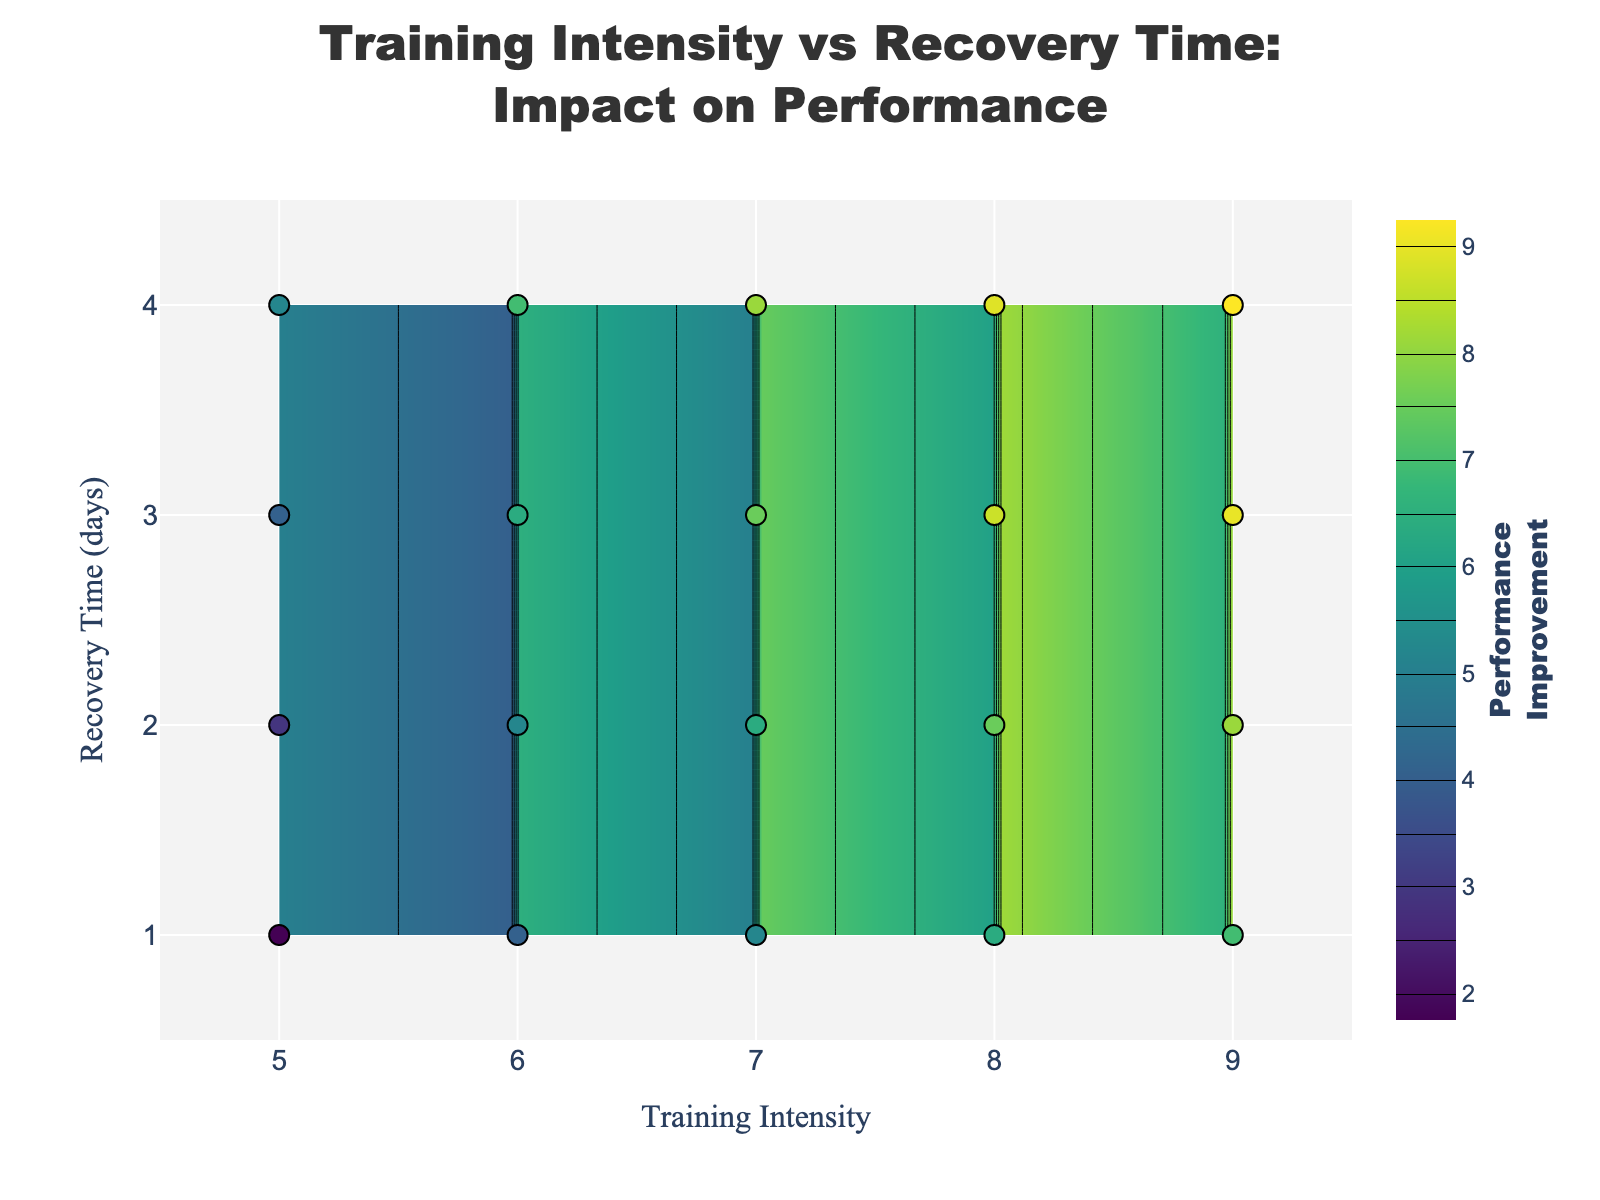What is the title of the plot? The title of the plot is displayed prominently at the top of the figure, indicating the main subject. It reads, "Training Intensity vs Recovery Time: Impact on Performance".
Answer: Training Intensity vs Recovery Time: Impact on Performance What are the axes labels on the plot? The labels for the x and y axes are shown on the plot. The x-axis is labeled "Training Intensity," and the y-axis is labeled "Recovery Time (days)."
Answer: Training Intensity, Recovery Time (days) How is the performance improvement represented in the plot? Performance improvement is represented by both the contour lines and the color gradient on the plot, with different colors indicating different levels of performance improvement. A color bar on the right side of the plot also shows the corresponding values.
Answer: Contours and color gradient Where is the highest performance improvement observed? The highest performance improvement can be identified by observing the contour lines and color gradients. It is found in the top-right area of the plot, where the training intensity is highest (around 9) and recovery times average around 4 days.
Answer: Top-right area What is the relationship between training intensity of 7 and recovery time of 2 days? To find the performance improvement, locate the point where training intensity is 7 and recovery time is 2 days on the plot. The associated color and contour line indicate a performance improvement value of approximately 6.
Answer: Approximately 6 What training intensity corresponds to a performance improvement of 8? To identify the training intensity for a performance improvement of 8, find the contour line labeled 8 on the plot and see where it crosses the training intensity axis. This occurs around a training intensity of 8 to 9.
Answer: Around 8 to 9 How does performance improvement change with increasing recovery time at a fixed training intensity of 6? By observing the contour lines at a fixed training intensity of 6, we see that as recovery time increases from 1 to 4 days, the performance improvement increases from around 4 to 6.5.
Answer: Increases from around 4 to 6.5 Compare the performance improvement for a training intensity of 8 with a recovery time of 1 day versus 3 days. Locate the points (8,1) and (8,3) on the plot and compare their associated colors or contour lines. The performance improvement for 1 day is approximately 6, while for 3 days it is around 8.
Answer: 6, 8 What is the color associated with the highest performance improvement? The highest performance improvement, which is found around a training intensity of 9 and recovery time of 4 days, is represented by the brightest color in the Viridis color scale depicted on the plot.
Answer: Brightest color on the scale Which scenario yields better performance improvement: a training intensity of 5 and recovery time of 4 days or a training intensity of 9 and recovery time of 3 days? Compare the points (5,4) and (9,3) on the plot. The performance improvement for (5,4) is around 5, whereas for (9,3) it is approximately 8.3, indicating the latter scenario is better.
Answer: Training intensity of 9 and recovery time of 3 days 